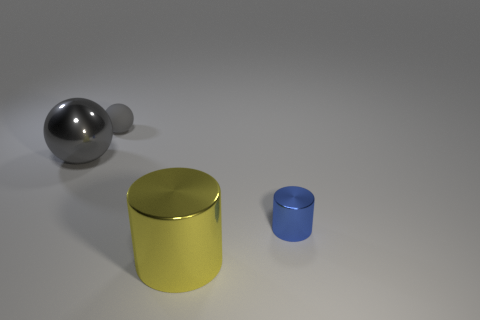Subtract all gray balls. How many were subtracted if there are1gray balls left? 1 Subtract 1 cylinders. How many cylinders are left? 1 Add 4 large metal cylinders. How many objects exist? 8 Subtract all yellow cylinders. How many cylinders are left? 1 Subtract all rubber spheres. Subtract all balls. How many objects are left? 1 Add 4 shiny objects. How many shiny objects are left? 7 Add 1 green metal cylinders. How many green metal cylinders exist? 1 Subtract 1 yellow cylinders. How many objects are left? 3 Subtract all brown spheres. Subtract all cyan cubes. How many spheres are left? 2 Subtract all brown blocks. How many blue spheres are left? 0 